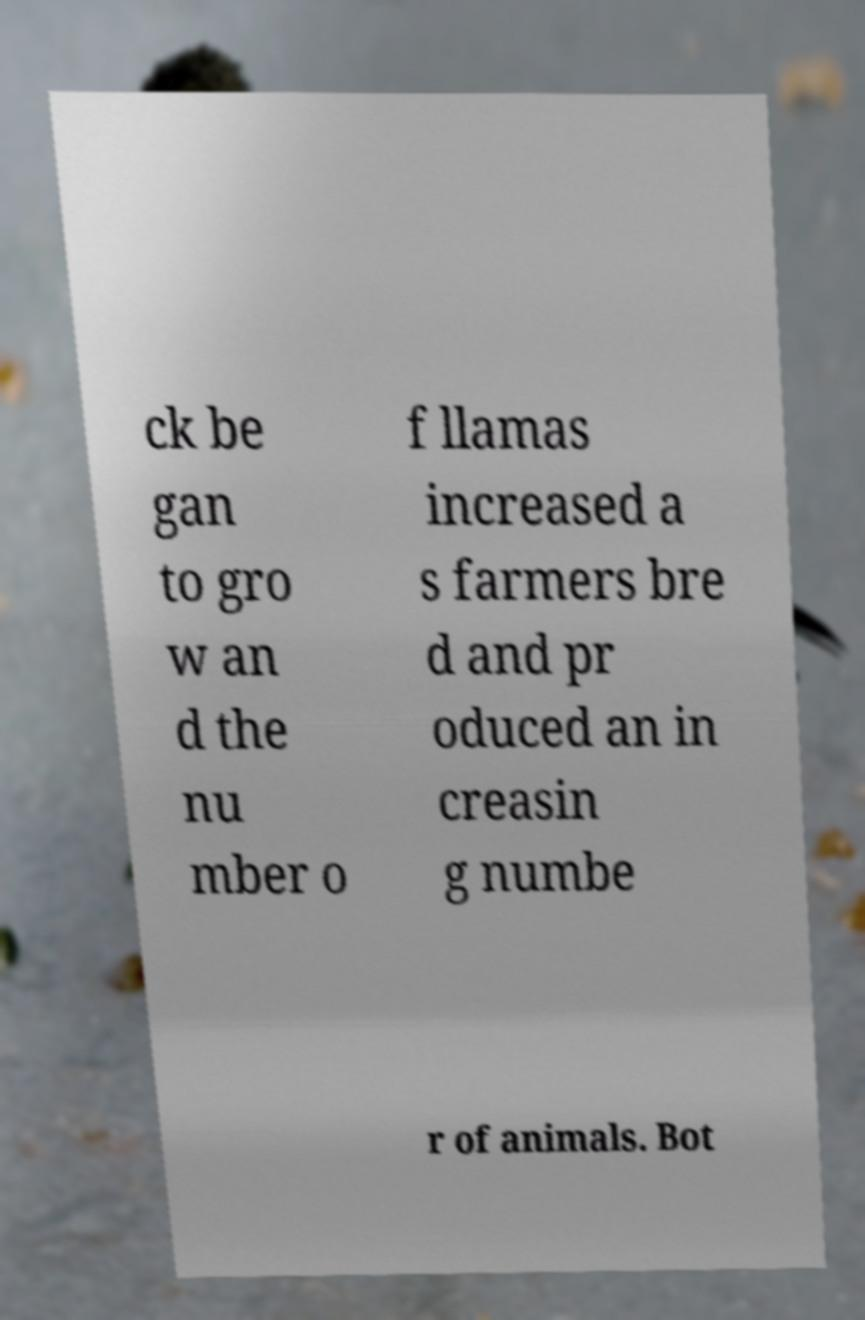Could you assist in decoding the text presented in this image and type it out clearly? ck be gan to gro w an d the nu mber o f llamas increased a s farmers bre d and pr oduced an in creasin g numbe r of animals. Bot 